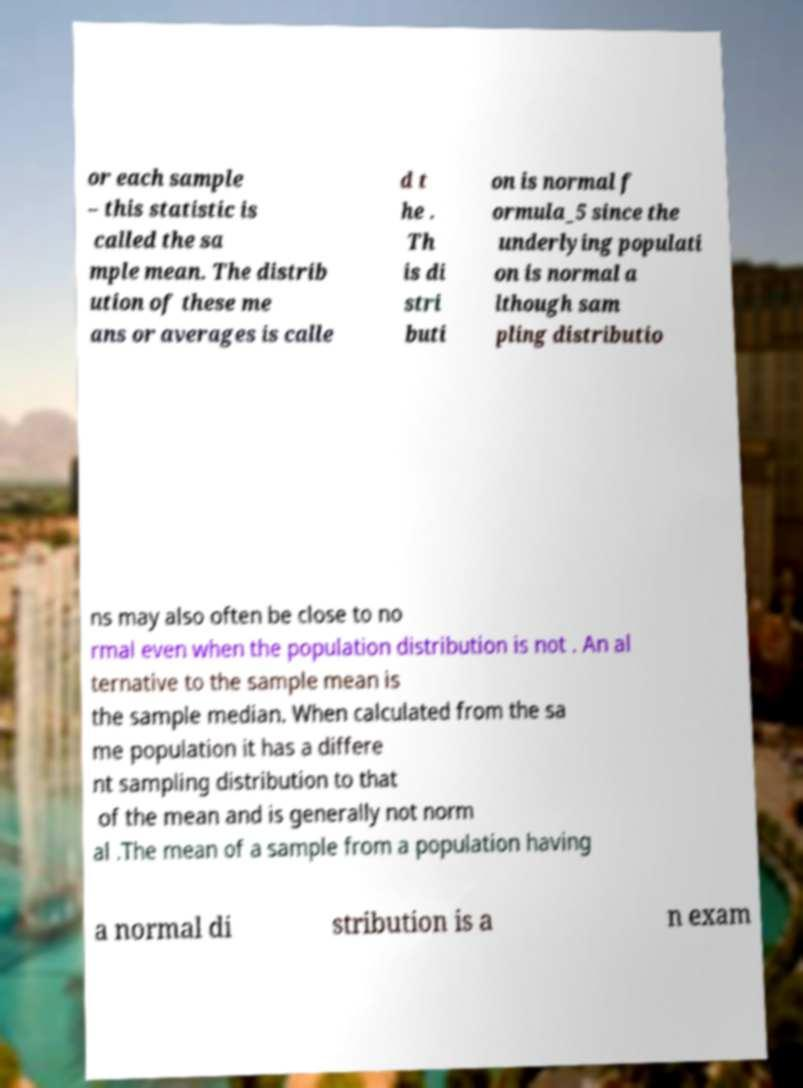Could you extract and type out the text from this image? or each sample – this statistic is called the sa mple mean. The distrib ution of these me ans or averages is calle d t he . Th is di stri buti on is normal f ormula_5 since the underlying populati on is normal a lthough sam pling distributio ns may also often be close to no rmal even when the population distribution is not . An al ternative to the sample mean is the sample median. When calculated from the sa me population it has a differe nt sampling distribution to that of the mean and is generally not norm al .The mean of a sample from a population having a normal di stribution is a n exam 